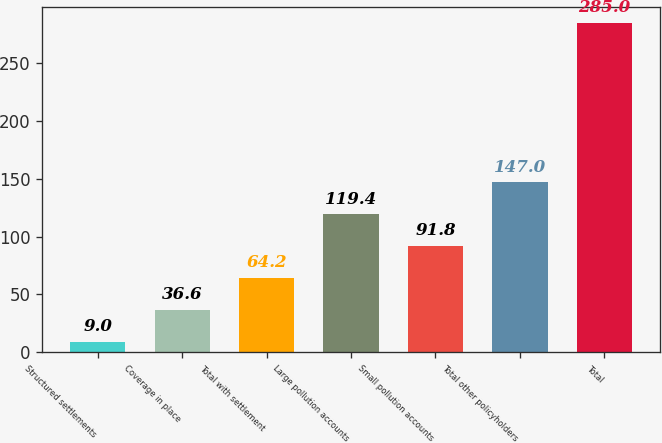Convert chart to OTSL. <chart><loc_0><loc_0><loc_500><loc_500><bar_chart><fcel>Structured settlements<fcel>Coverage in place<fcel>Total with settlement<fcel>Large pollution accounts<fcel>Small pollution accounts<fcel>Total other policyholders<fcel>Total<nl><fcel>9<fcel>36.6<fcel>64.2<fcel>119.4<fcel>91.8<fcel>147<fcel>285<nl></chart> 